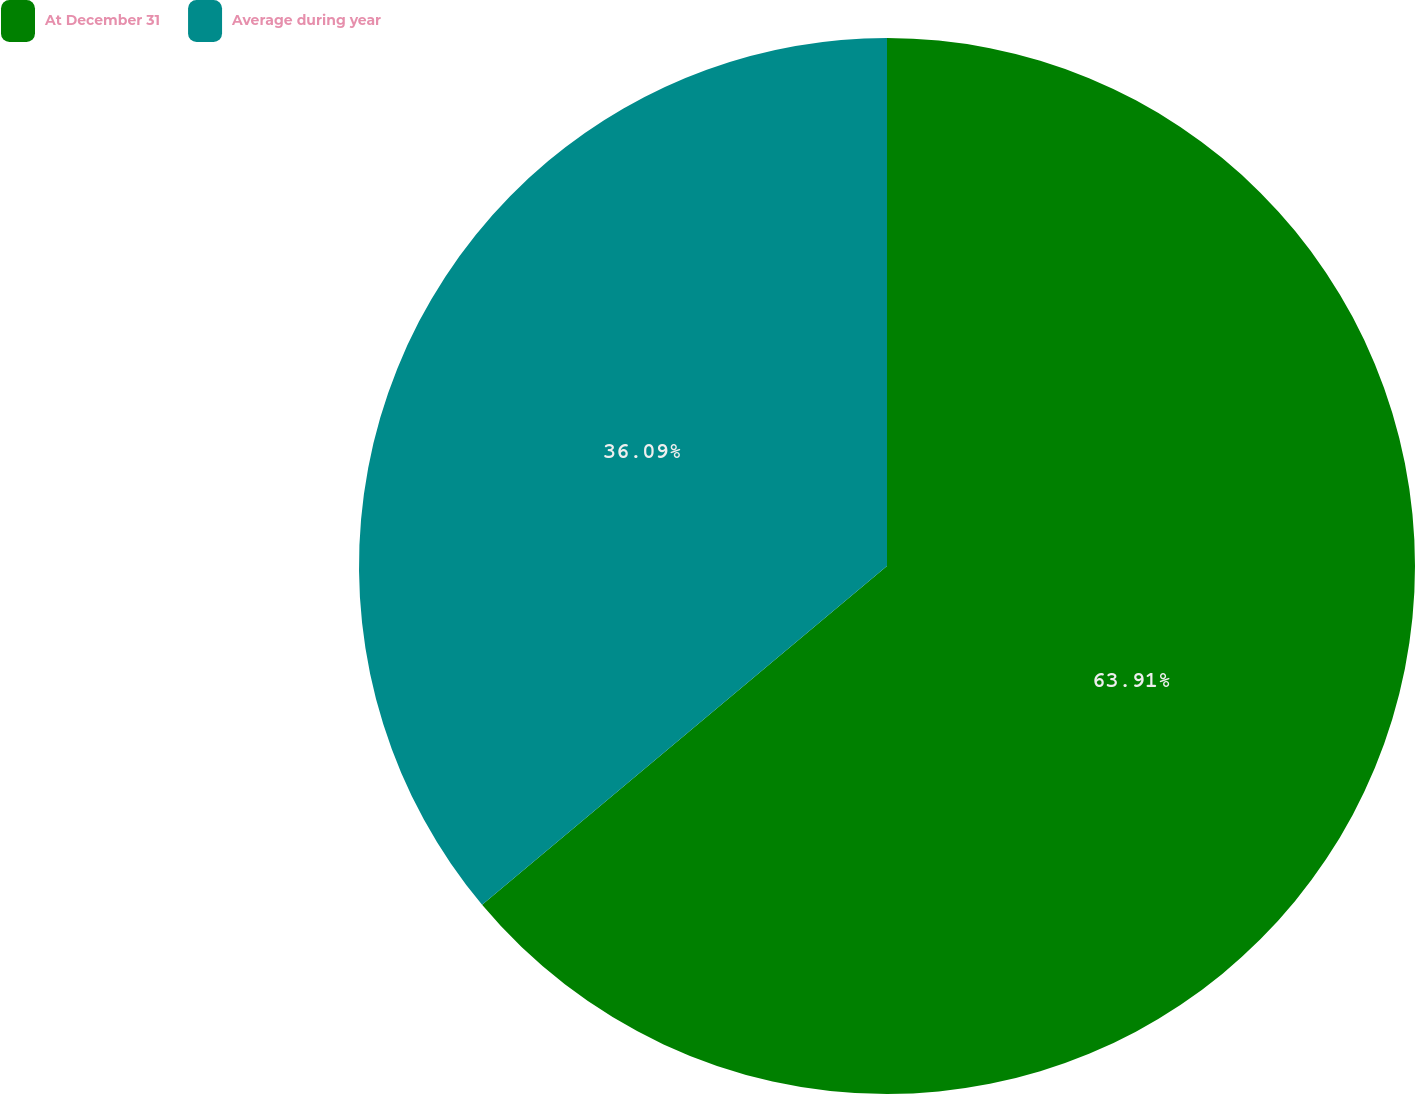Convert chart. <chart><loc_0><loc_0><loc_500><loc_500><pie_chart><fcel>At December 31<fcel>Average during year<nl><fcel>63.91%<fcel>36.09%<nl></chart> 